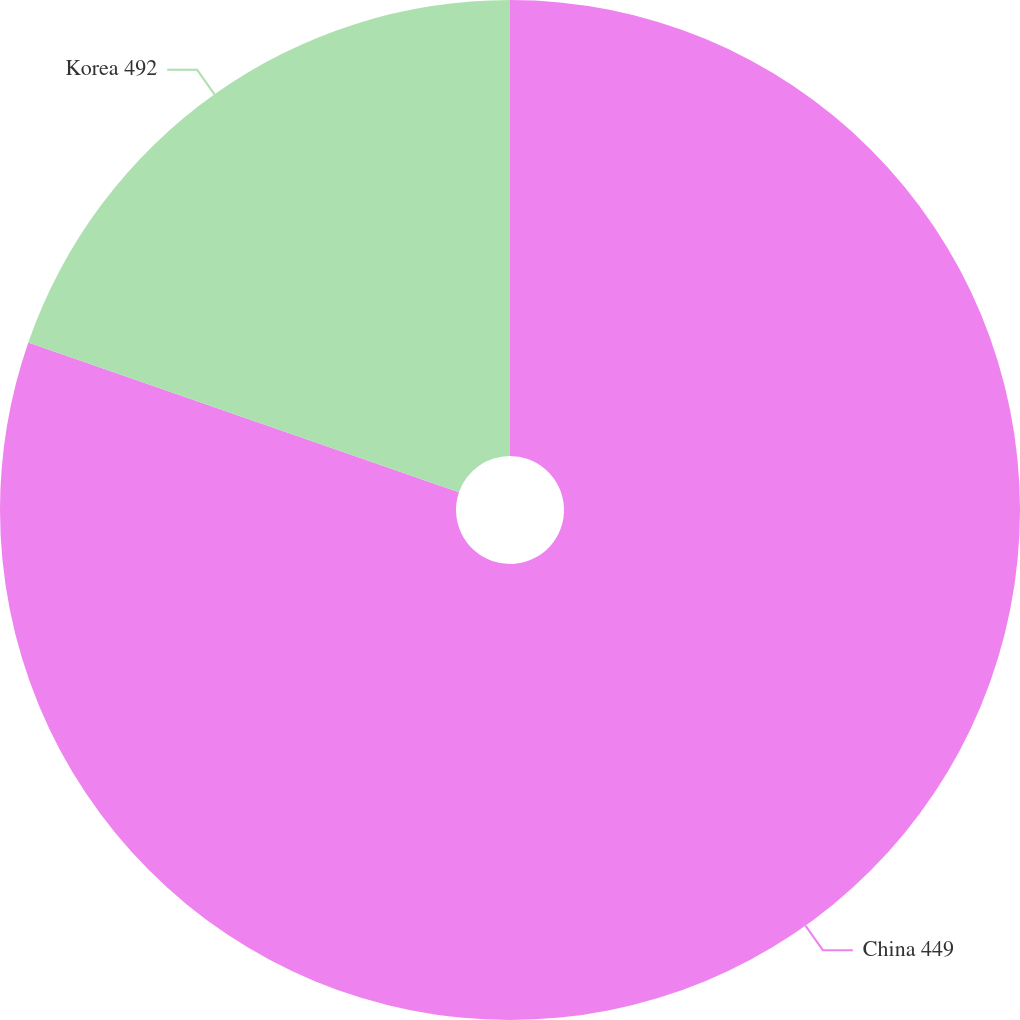Convert chart to OTSL. <chart><loc_0><loc_0><loc_500><loc_500><pie_chart><fcel>China 449<fcel>Korea 492<nl><fcel>80.33%<fcel>19.67%<nl></chart> 